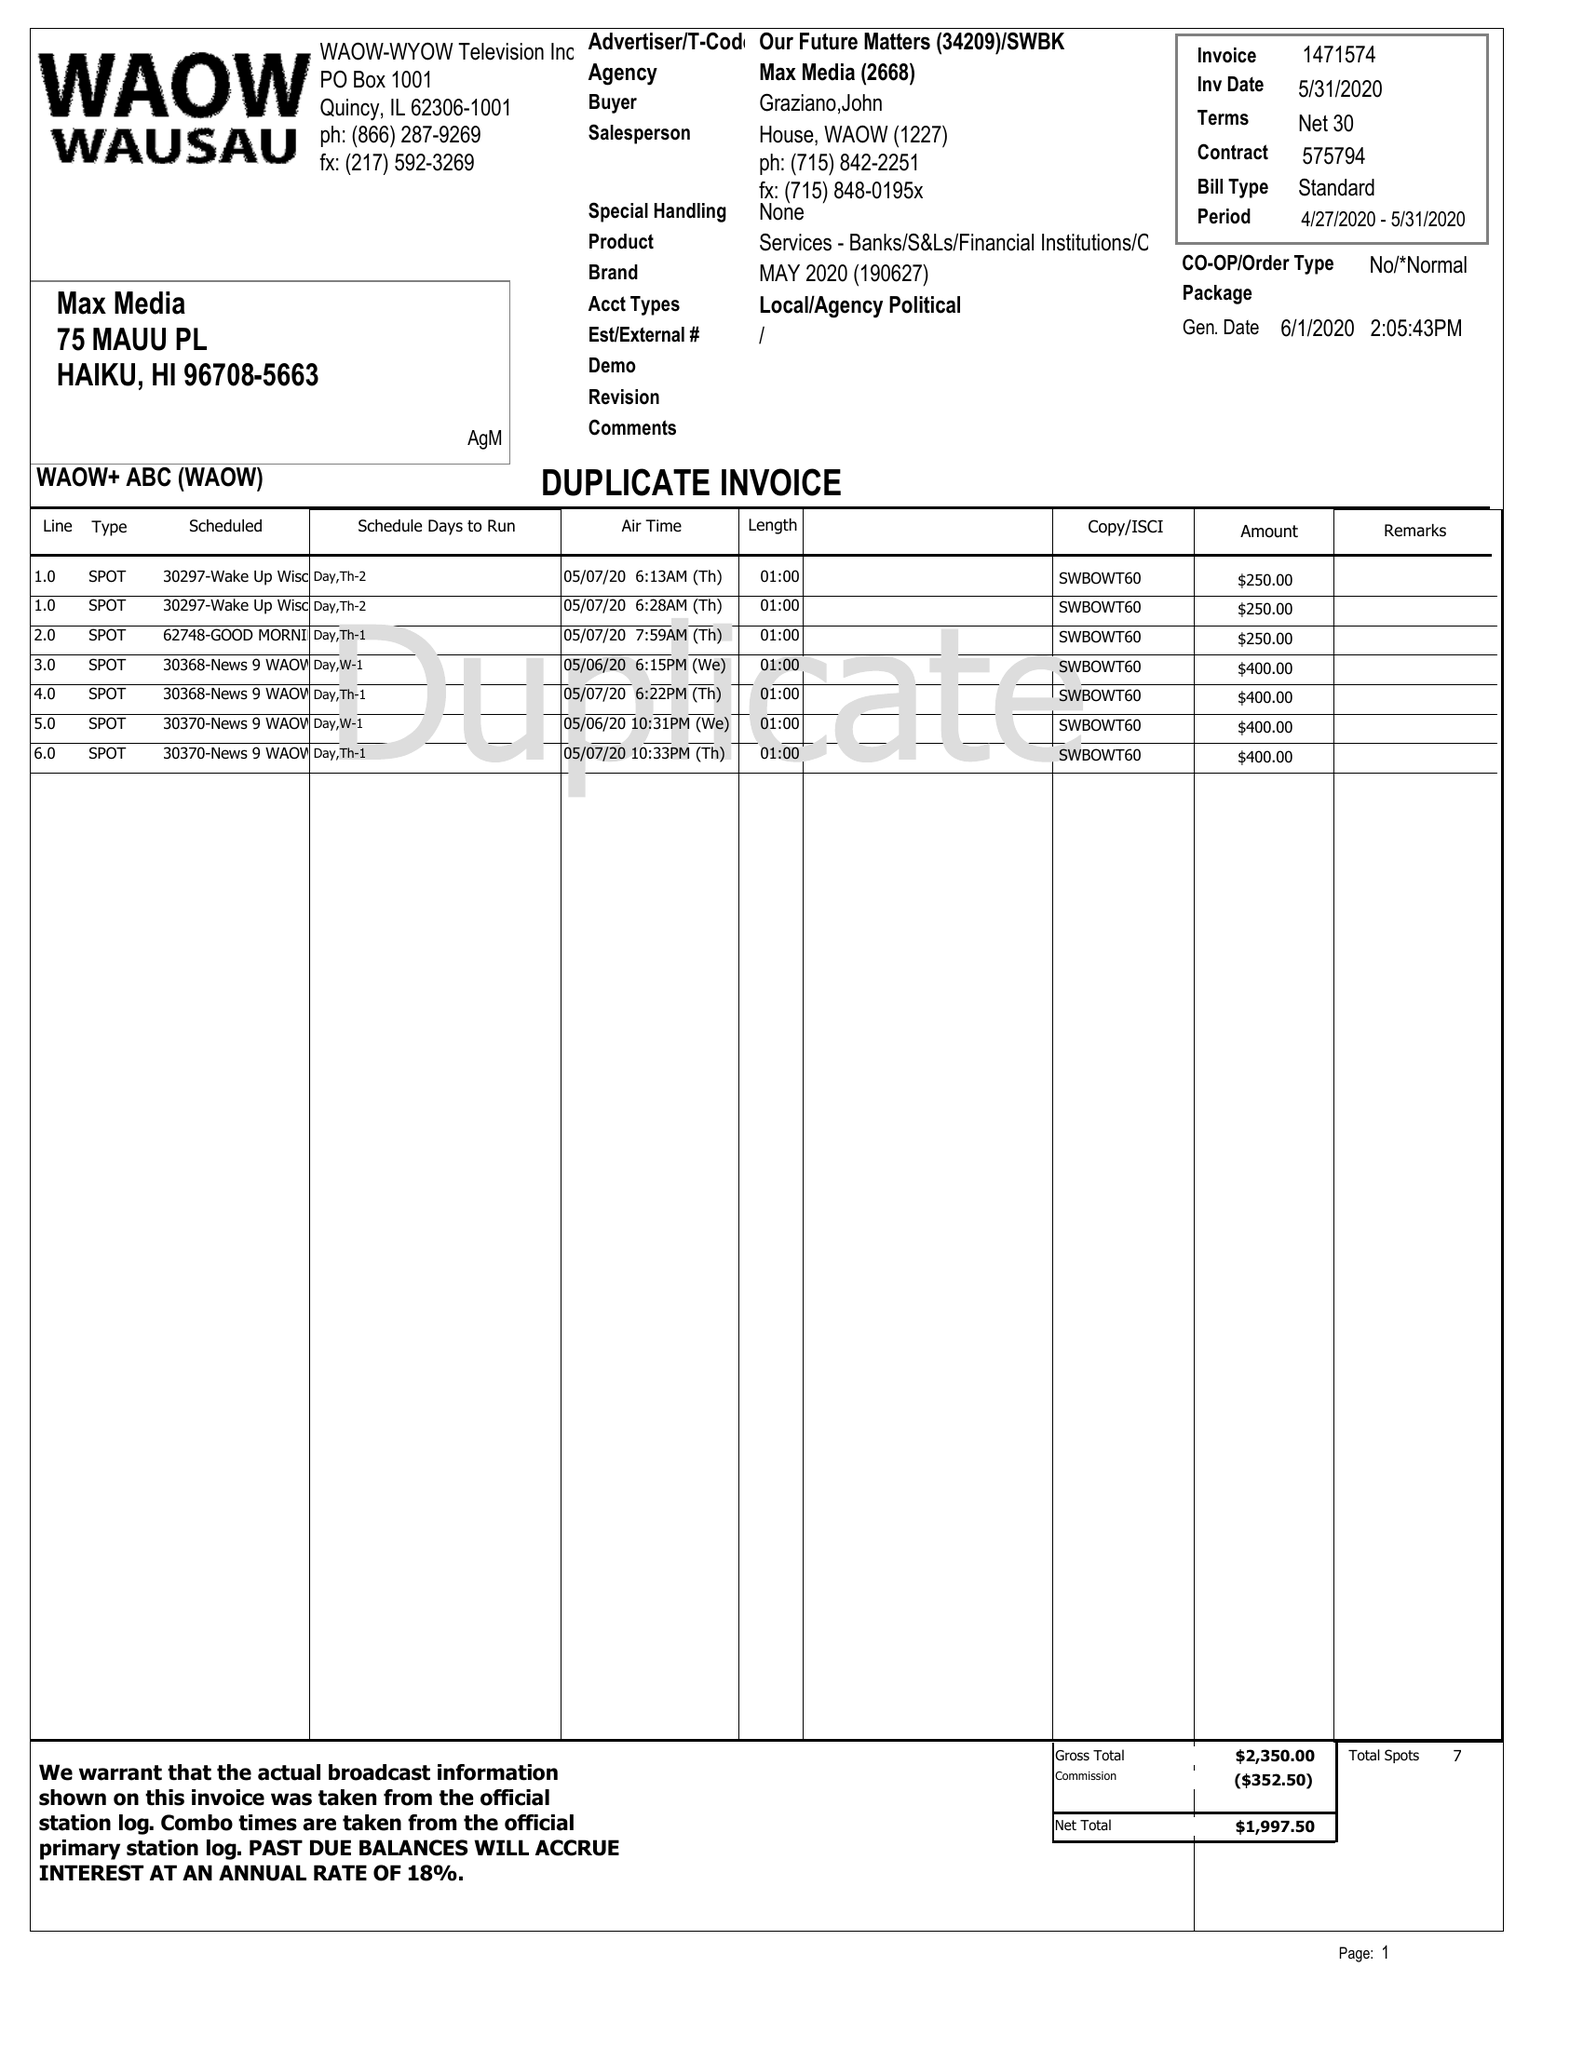What is the value for the gross_amount?
Answer the question using a single word or phrase. 1997.50 